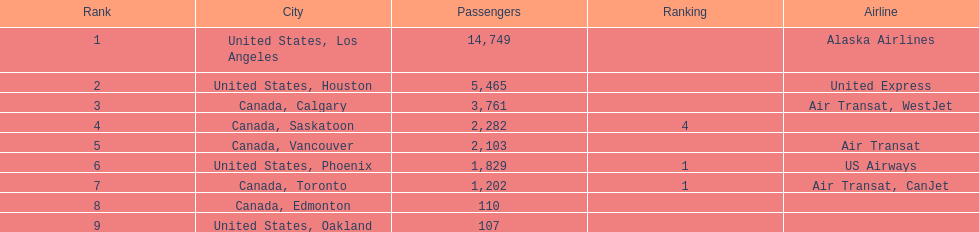The minimum number of passengers was from which city? United States, Oakland. 